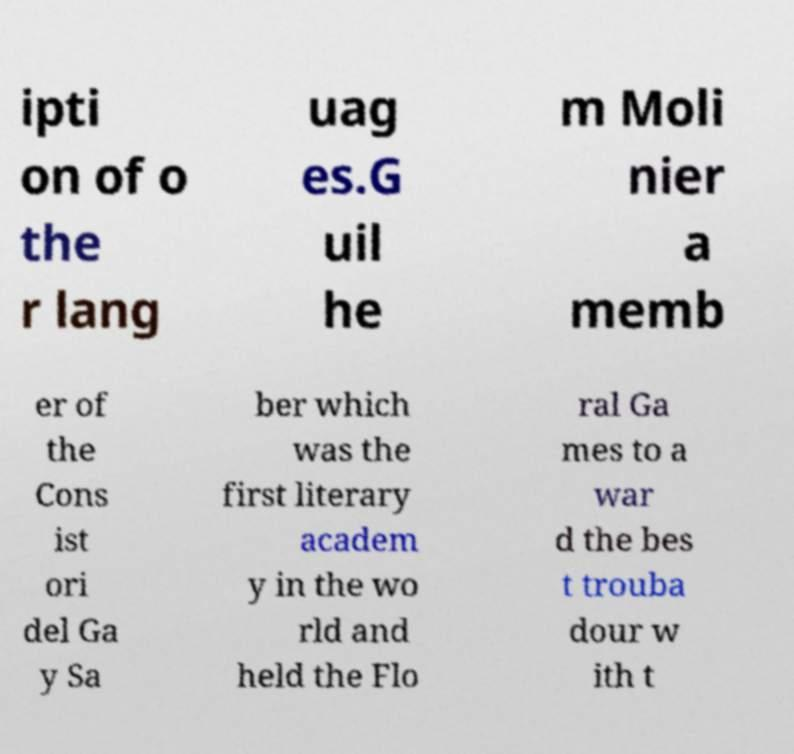Please identify and transcribe the text found in this image. ipti on of o the r lang uag es.G uil he m Moli nier a memb er of the Cons ist ori del Ga y Sa ber which was the first literary academ y in the wo rld and held the Flo ral Ga mes to a war d the bes t trouba dour w ith t 